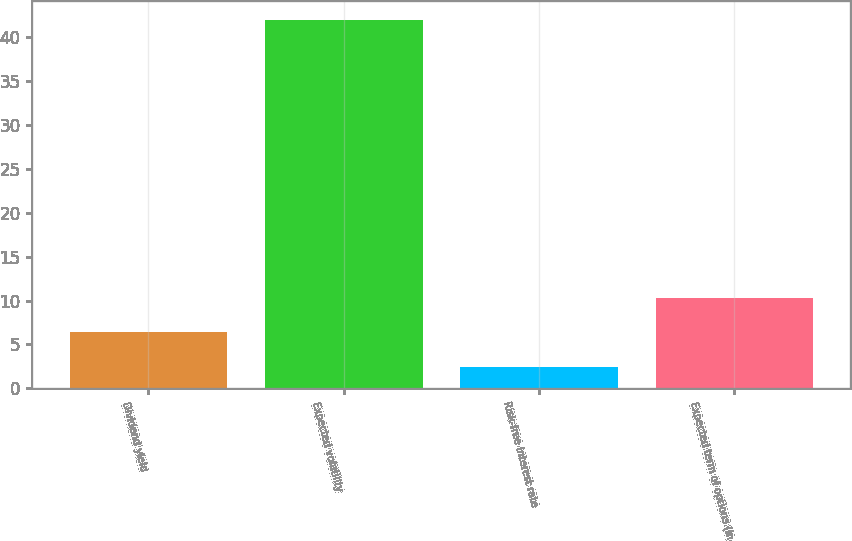<chart> <loc_0><loc_0><loc_500><loc_500><bar_chart><fcel>Dividend yield<fcel>Expected volatility<fcel>Risk-free interest rate<fcel>Expected term of options (in<nl><fcel>6.36<fcel>41.97<fcel>2.4<fcel>10.32<nl></chart> 